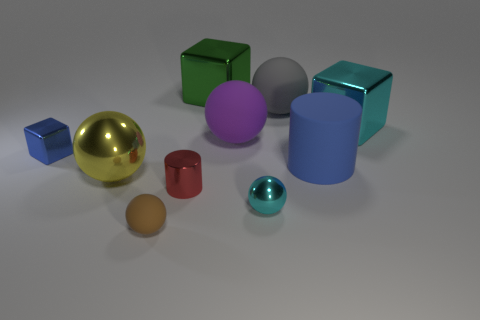What color is the tiny cube that is made of the same material as the small red thing?
Offer a very short reply. Blue. There is a cyan thing in front of the purple matte thing; what is it made of?
Your answer should be compact. Metal. There is a tiny blue object; does it have the same shape as the cyan metal thing that is behind the purple matte object?
Keep it short and to the point. Yes. What is the material of the large sphere that is both to the left of the tiny cyan sphere and behind the large yellow metallic thing?
Make the answer very short. Rubber. The cylinder that is the same size as the cyan ball is what color?
Provide a succinct answer. Red. Is the cyan cube made of the same material as the small ball that is behind the brown rubber object?
Give a very brief answer. Yes. What number of other things are the same size as the red metallic cylinder?
Provide a succinct answer. 3. Is there a metallic cube left of the metallic block on the left side of the matte ball in front of the big blue thing?
Your answer should be compact. No. What is the size of the green metallic block?
Ensure brevity in your answer.  Large. There is a cyan shiny thing behind the red thing; how big is it?
Offer a terse response. Large. 